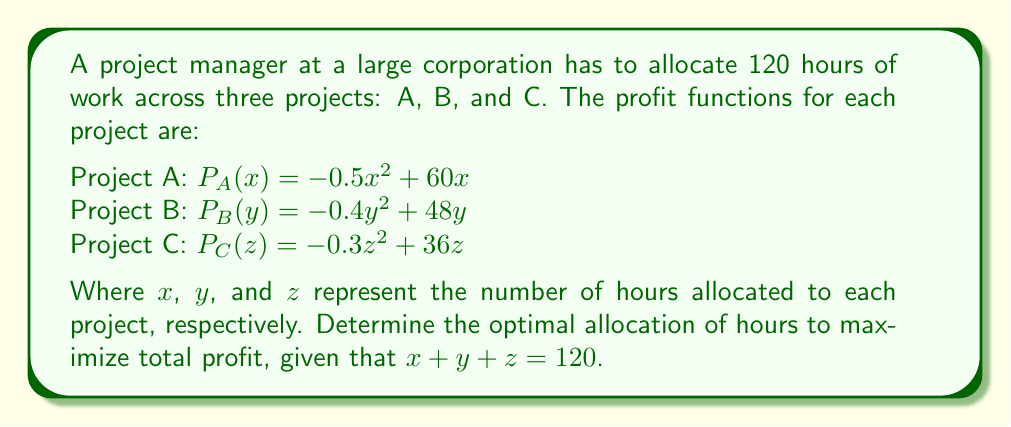What is the answer to this math problem? 1. We need to maximize the total profit function:
   $P(x,y,z) = P_A(x) + P_B(y) + P_C(z)$
   $= (-0.5x^2 + 60x) + (-0.4y^2 + 48y) + (-0.3z^2 + 36z)$

2. We have the constraint: $x + y + z = 120$

3. Use the method of Lagrange multipliers. Let $\lambda$ be the Lagrange multiplier:
   $L(x,y,z,\lambda) = P(x,y,z) - \lambda(x + y + z - 120)$

4. Take partial derivatives and set them to zero:
   $\frac{\partial L}{\partial x} = -x + 60 - \lambda = 0$
   $\frac{\partial L}{\partial y} = -0.8y + 48 - \lambda = 0$
   $\frac{\partial L}{\partial z} = -0.6z + 36 - \lambda = 0$
   $\frac{\partial L}{\partial \lambda} = x + y + z - 120 = 0$

5. From these equations:
   $x = 60 - \lambda$
   $y = 60 - 1.25\lambda$
   $z = 60 - 1.67\lambda$

6. Substitute into the constraint equation:
   $(60 - \lambda) + (60 - 1.25\lambda) + (60 - 1.67\lambda) = 120$
   $180 - 3.92\lambda = 120$
   $60 = 3.92\lambda$
   $\lambda \approx 15.31$

7. Substitute back to find $x$, $y$, and $z$:
   $x \approx 44.69$
   $y \approx 40.86$
   $z \approx 34.45$

8. Round to the nearest whole number of hours:
   $x = 45$, $y = 41$, $z = 34$
Answer: Project A: 45 hours, Project B: 41 hours, Project C: 34 hours 